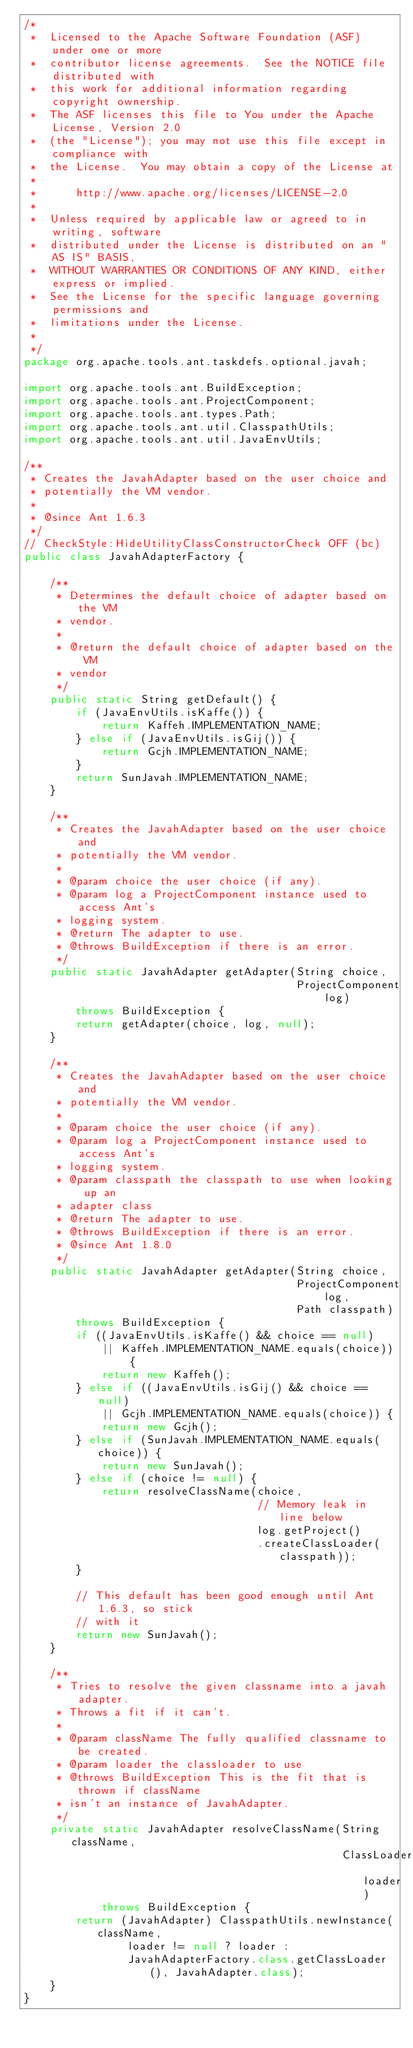Convert code to text. <code><loc_0><loc_0><loc_500><loc_500><_Java_>/*
 *  Licensed to the Apache Software Foundation (ASF) under one or more
 *  contributor license agreements.  See the NOTICE file distributed with
 *  this work for additional information regarding copyright ownership.
 *  The ASF licenses this file to You under the Apache License, Version 2.0
 *  (the "License"); you may not use this file except in compliance with
 *  the License.  You may obtain a copy of the License at
 *
 *      http://www.apache.org/licenses/LICENSE-2.0
 *
 *  Unless required by applicable law or agreed to in writing, software
 *  distributed under the License is distributed on an "AS IS" BASIS,
 *  WITHOUT WARRANTIES OR CONDITIONS OF ANY KIND, either express or implied.
 *  See the License for the specific language governing permissions and
 *  limitations under the License.
 *
 */
package org.apache.tools.ant.taskdefs.optional.javah;

import org.apache.tools.ant.BuildException;
import org.apache.tools.ant.ProjectComponent;
import org.apache.tools.ant.types.Path;
import org.apache.tools.ant.util.ClasspathUtils;
import org.apache.tools.ant.util.JavaEnvUtils;

/**
 * Creates the JavahAdapter based on the user choice and
 * potentially the VM vendor.
 *
 * @since Ant 1.6.3
 */
// CheckStyle:HideUtilityClassConstructorCheck OFF (bc)
public class JavahAdapterFactory {

    /**
     * Determines the default choice of adapter based on the VM
     * vendor.
     *
     * @return the default choice of adapter based on the VM
     * vendor
     */
    public static String getDefault() {
        if (JavaEnvUtils.isKaffe()) {
            return Kaffeh.IMPLEMENTATION_NAME;
        } else if (JavaEnvUtils.isGij()) {
            return Gcjh.IMPLEMENTATION_NAME;
        }
        return SunJavah.IMPLEMENTATION_NAME;
    }

    /**
     * Creates the JavahAdapter based on the user choice and
     * potentially the VM vendor.
     *
     * @param choice the user choice (if any).
     * @param log a ProjectComponent instance used to access Ant's
     * logging system.
     * @return The adapter to use.
     * @throws BuildException if there is an error.
     */
    public static JavahAdapter getAdapter(String choice,
                                          ProjectComponent log)
        throws BuildException {
        return getAdapter(choice, log, null);
    }

    /**
     * Creates the JavahAdapter based on the user choice and
     * potentially the VM vendor.
     *
     * @param choice the user choice (if any).
     * @param log a ProjectComponent instance used to access Ant's
     * logging system.
     * @param classpath the classpath to use when looking up an
     * adapter class
     * @return The adapter to use.
     * @throws BuildException if there is an error.
     * @since Ant 1.8.0
     */
    public static JavahAdapter getAdapter(String choice,
                                          ProjectComponent log,
                                          Path classpath)
        throws BuildException {
        if ((JavaEnvUtils.isKaffe() && choice == null)
            || Kaffeh.IMPLEMENTATION_NAME.equals(choice)) {
            return new Kaffeh();
        } else if ((JavaEnvUtils.isGij() && choice == null)
            || Gcjh.IMPLEMENTATION_NAME.equals(choice)) {
            return new Gcjh();
        } else if (SunJavah.IMPLEMENTATION_NAME.equals(choice)) {
            return new SunJavah();
        } else if (choice != null) {
            return resolveClassName(choice,
                                    // Memory leak in line below
                                    log.getProject()
                                    .createClassLoader(classpath));
        }

        // This default has been good enough until Ant 1.6.3, so stick
        // with it
        return new SunJavah();
    }

    /**
     * Tries to resolve the given classname into a javah adapter.
     * Throws a fit if it can't.
     *
     * @param className The fully qualified classname to be created.
     * @param loader the classloader to use
     * @throws BuildException This is the fit that is thrown if className
     * isn't an instance of JavahAdapter.
     */
    private static JavahAdapter resolveClassName(String className,
                                                 ClassLoader loader)
            throws BuildException {
        return (JavahAdapter) ClasspathUtils.newInstance(className,
                loader != null ? loader :
                JavahAdapterFactory.class.getClassLoader(), JavahAdapter.class);
    }
}
</code> 